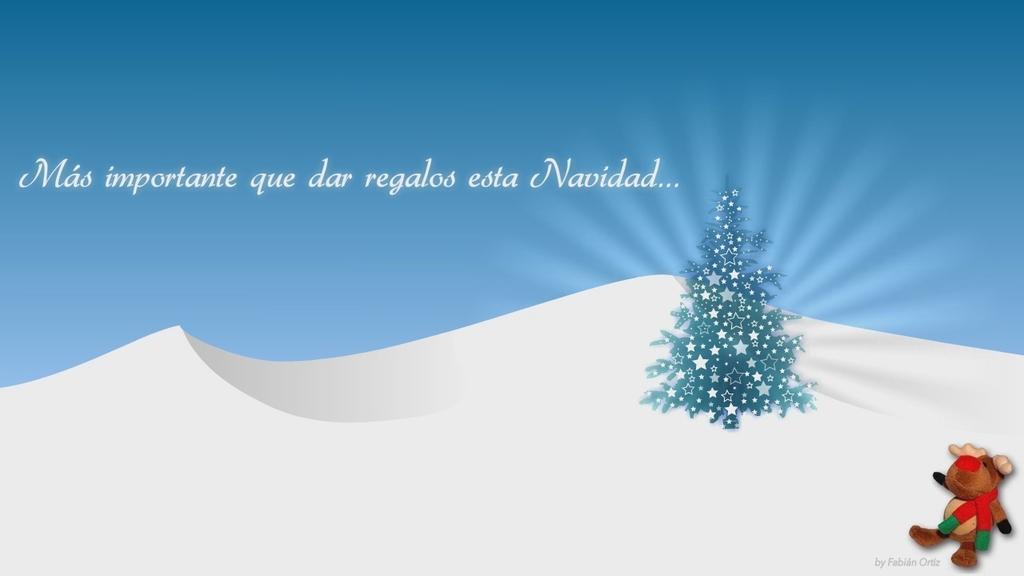How would you summarize this image in a sentence or two? This image is an animation. In this image we can see an xmas tree and there is a soft toy. We can see some text and there are hills. 